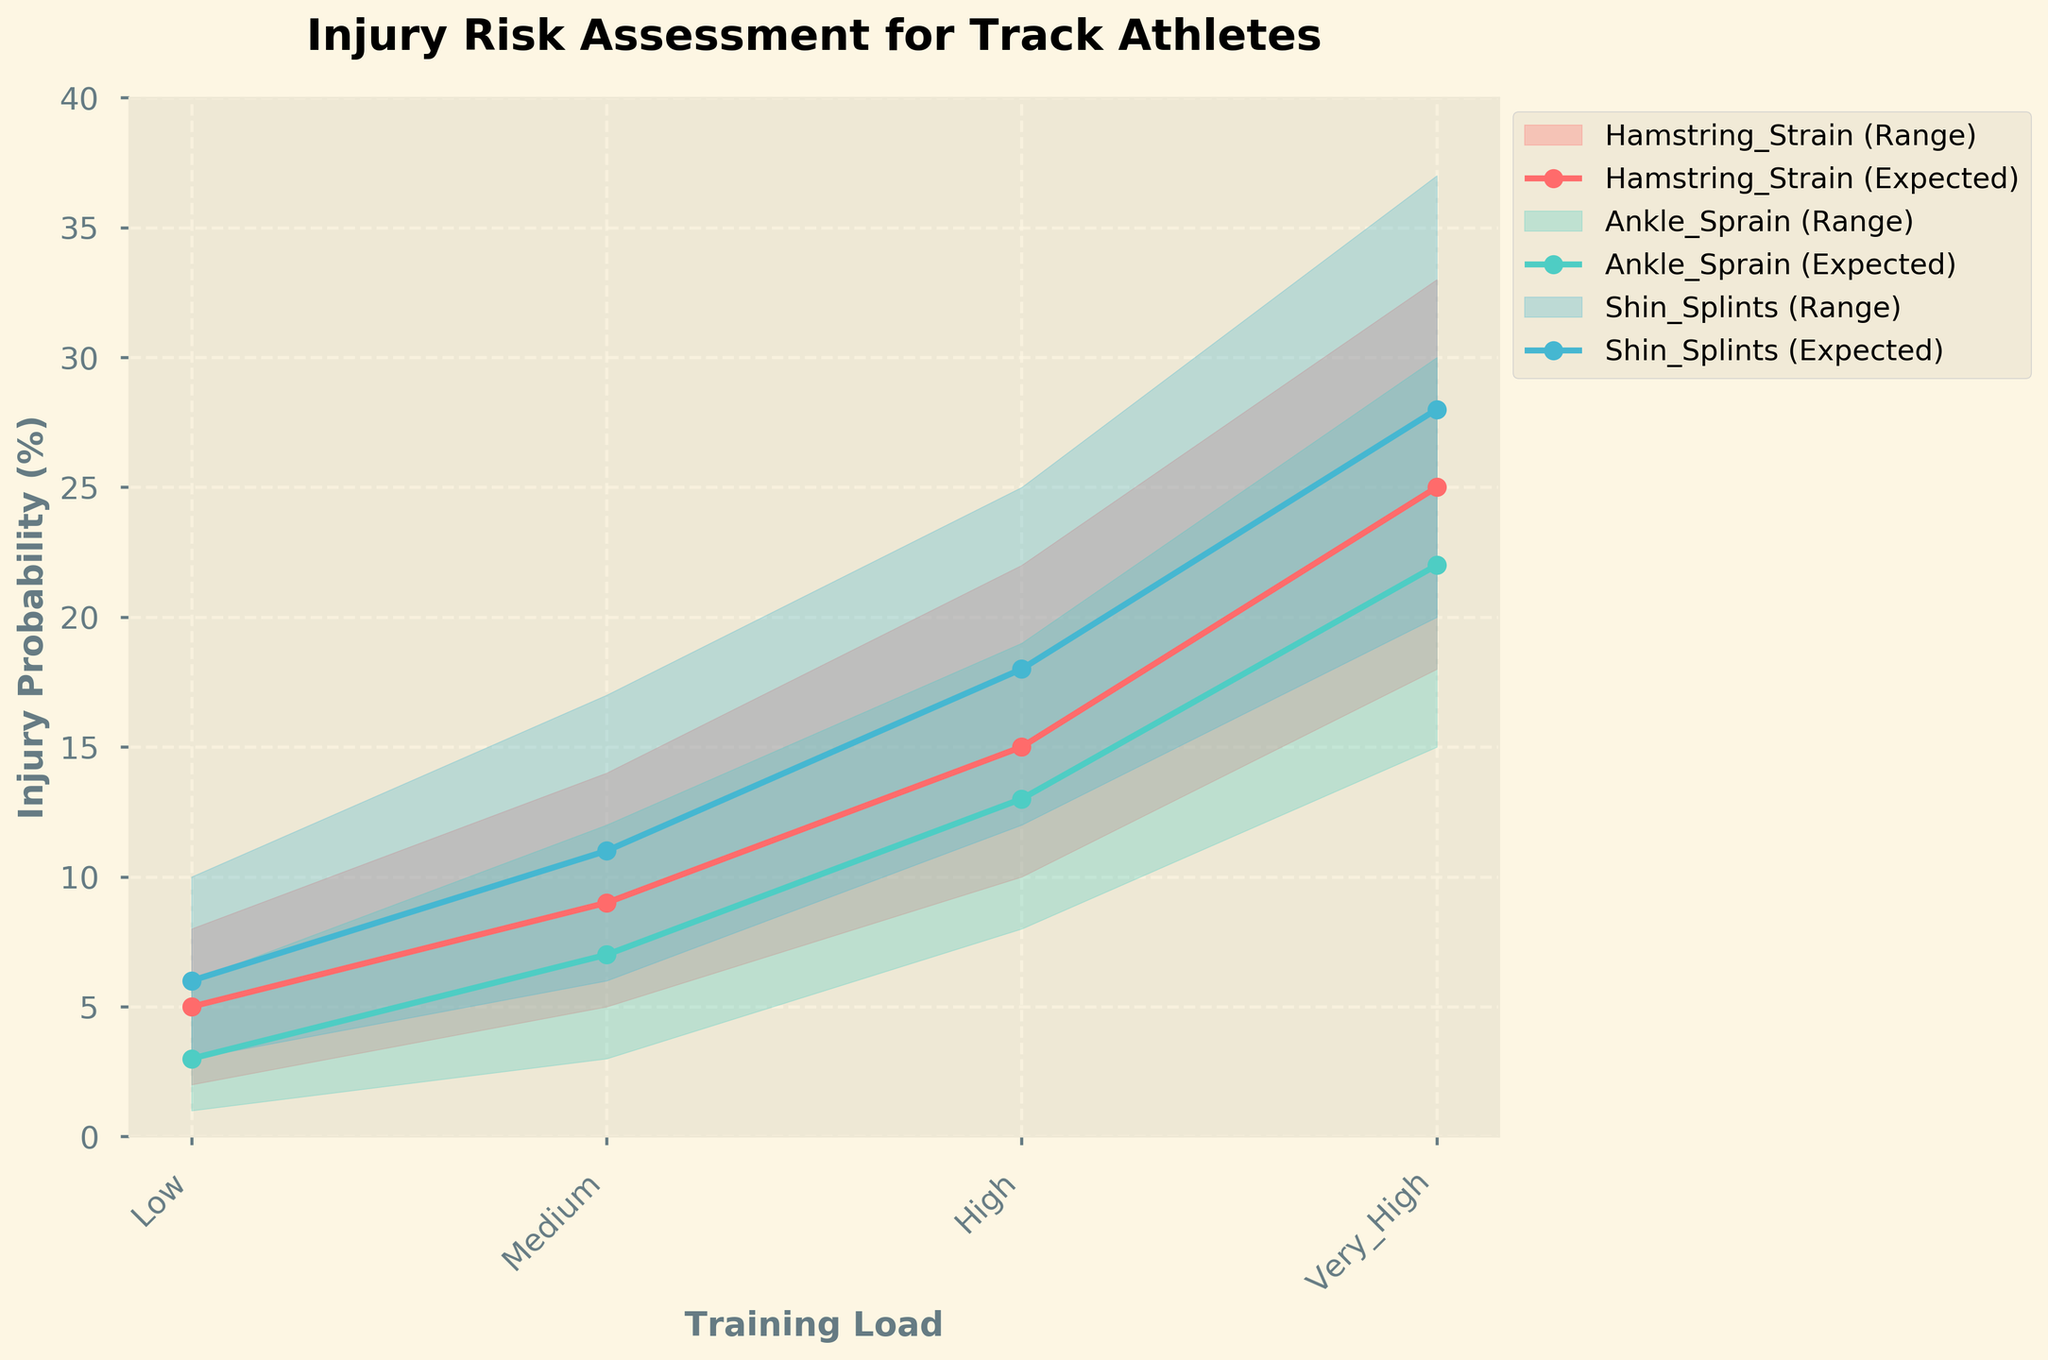What's the title of the figure? The title of the figure is positioned at the top and is stylized with a larger and bold font to make it prominent.
Answer: Injury Risk Assessment for Track Athletes What are the labels of the axes? The x-axis label is placed below the horizontal axis and reads "Training Load," while the y-axis label is positioned to the left of the vertical axis and reads "Injury Probability (%)".
Answer: Training Load; Injury Probability (%) What training load category has the highest expected probability of hamstring strain? The expected probability of hamstring strain increases with the training load categories. The highest expected probability occurs in the "Very High" training load category, noticeable on the plot by the corresponding markers.
Answer: Very High Which injury type has the broadest probability range under medium training load? The width of the probability range is the difference between the high and low probabilities for each injury type. For medium training load, Shin Splints has a range from 6% to 17%, which is the broadest.
Answer: Shin Splints Compare the expected probabilities of ankle sprain and shin splints under high training load. For high training load, the expected probability of ankle sprain is 13%, and the expected probability of shin splints is 18%, as indicated by the markers for each injury type on the plot.
Answer: Shin Splints is higher How does the expected probability of hamstring strain change from low to very high training load? The expected probabilities for hamstring strain are plotted along the different training load categories (Low: 5%, Medium: 9%, High: 15%, Very High: 25%). This shows a gradual increase.
Answer: Increases from 5% to 25% In which training load category is the highest spread (difference) of injury probability for any single injury type? The spread is the difference between high and low probabilities. For hamstring strain, the difference is largest in the "Very High" category (33% - 18% = 15%). This is visualized by the widest span of the shaded area.
Answer: Very High What is the expected probability of ankle sprain at medium training load? The expected probability for ankle sprain at medium training load is indicated by the plotted points for ankle sprain in the medium training load category.
Answer: 7% Which injury type consistently has the highest probability across all training loads? By comparing the probabilities for all injury types across different training loads, it's noticeable that Shin Splints consistently has the highest probabilities.
Answer: Shin Splints 